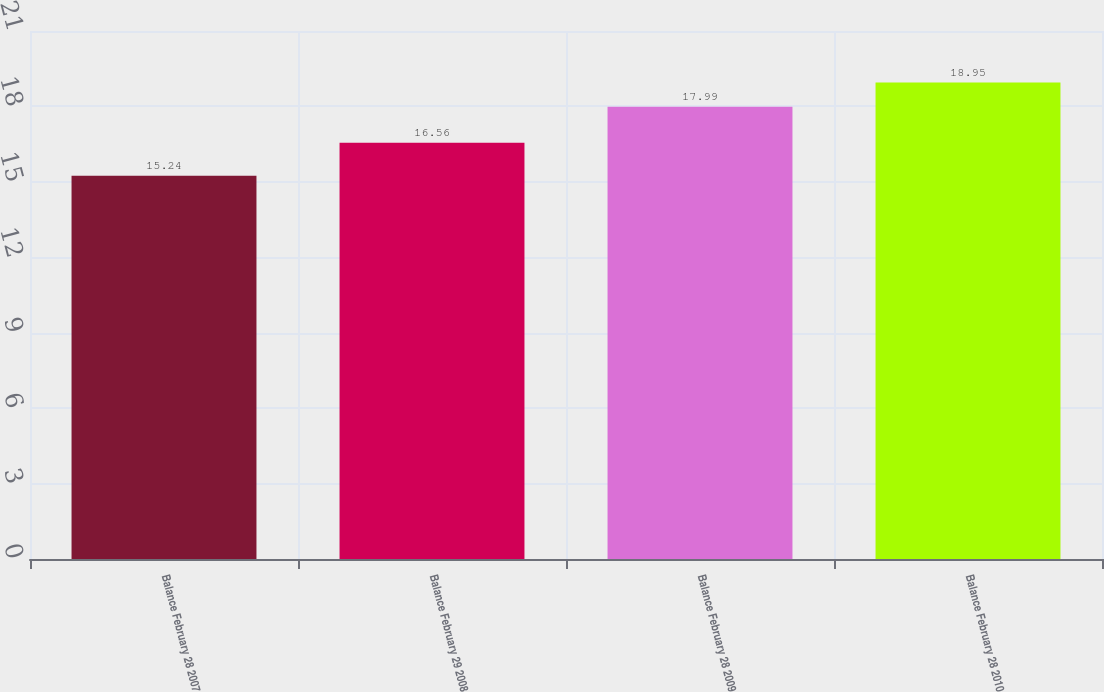<chart> <loc_0><loc_0><loc_500><loc_500><bar_chart><fcel>Balance February 28 2007<fcel>Balance February 29 2008<fcel>Balance February 28 2009<fcel>Balance February 28 2010<nl><fcel>15.24<fcel>16.56<fcel>17.99<fcel>18.95<nl></chart> 